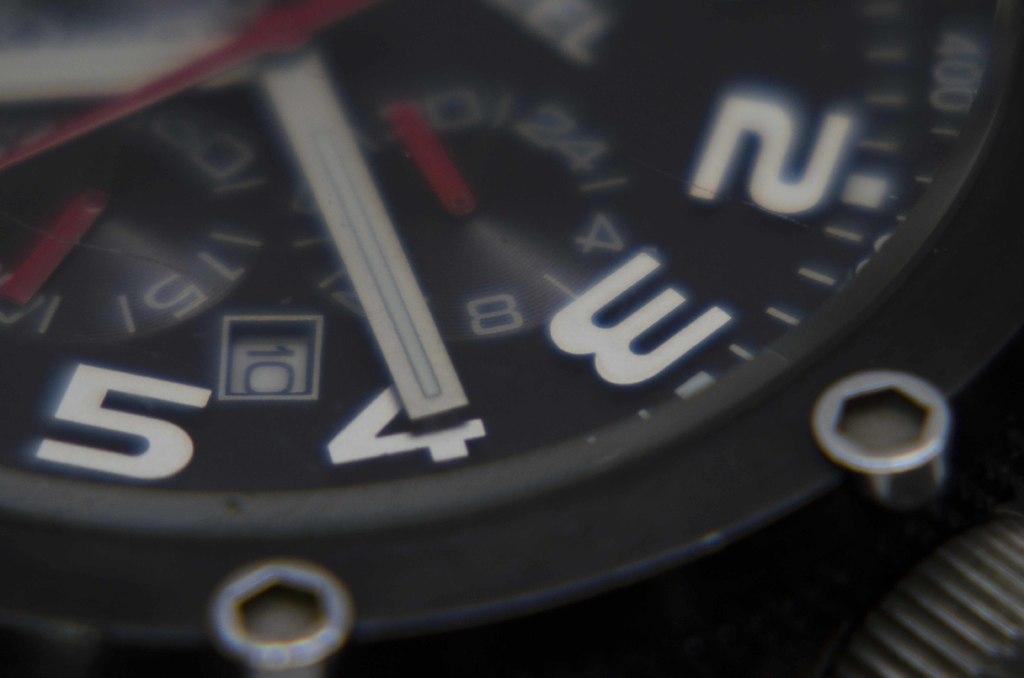What number is the big hand on?
Provide a short and direct response. 4. What date is it?
Offer a very short reply. 10. 